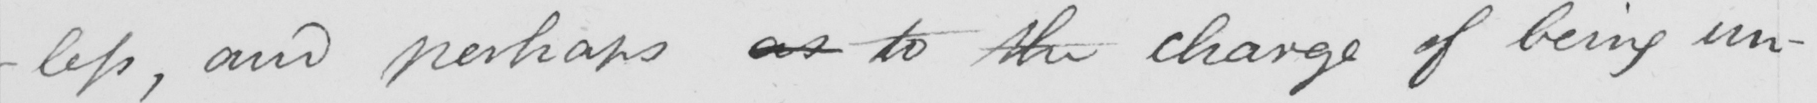Please transcribe the handwritten text in this image. -less , and perhaps as to the charge of being un- 